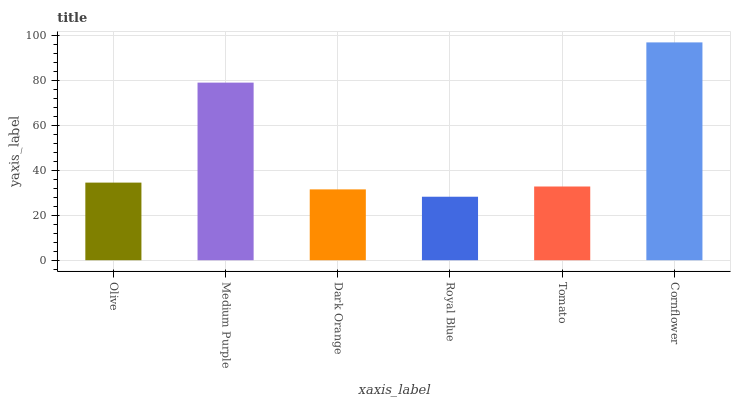Is Medium Purple the minimum?
Answer yes or no. No. Is Medium Purple the maximum?
Answer yes or no. No. Is Medium Purple greater than Olive?
Answer yes or no. Yes. Is Olive less than Medium Purple?
Answer yes or no. Yes. Is Olive greater than Medium Purple?
Answer yes or no. No. Is Medium Purple less than Olive?
Answer yes or no. No. Is Olive the high median?
Answer yes or no. Yes. Is Tomato the low median?
Answer yes or no. Yes. Is Medium Purple the high median?
Answer yes or no. No. Is Olive the low median?
Answer yes or no. No. 